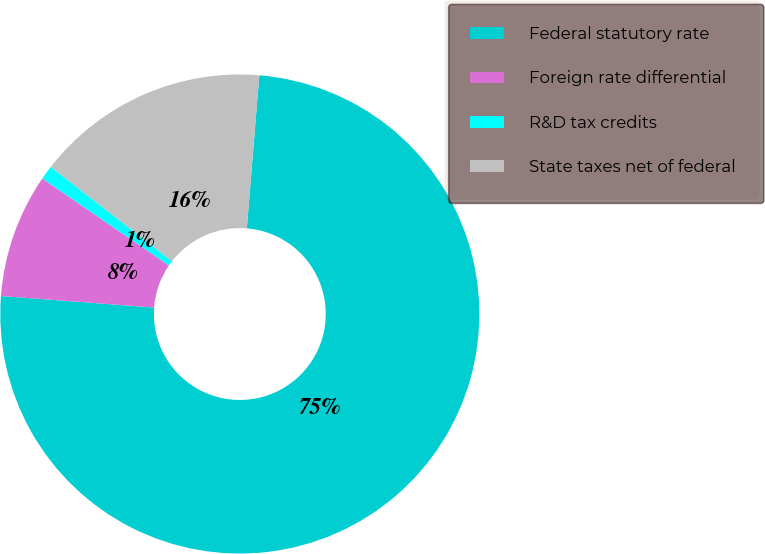<chart> <loc_0><loc_0><loc_500><loc_500><pie_chart><fcel>Federal statutory rate<fcel>Foreign rate differential<fcel>R&D tax credits<fcel>State taxes net of federal<nl><fcel>74.9%<fcel>8.37%<fcel>0.96%<fcel>15.77%<nl></chart> 